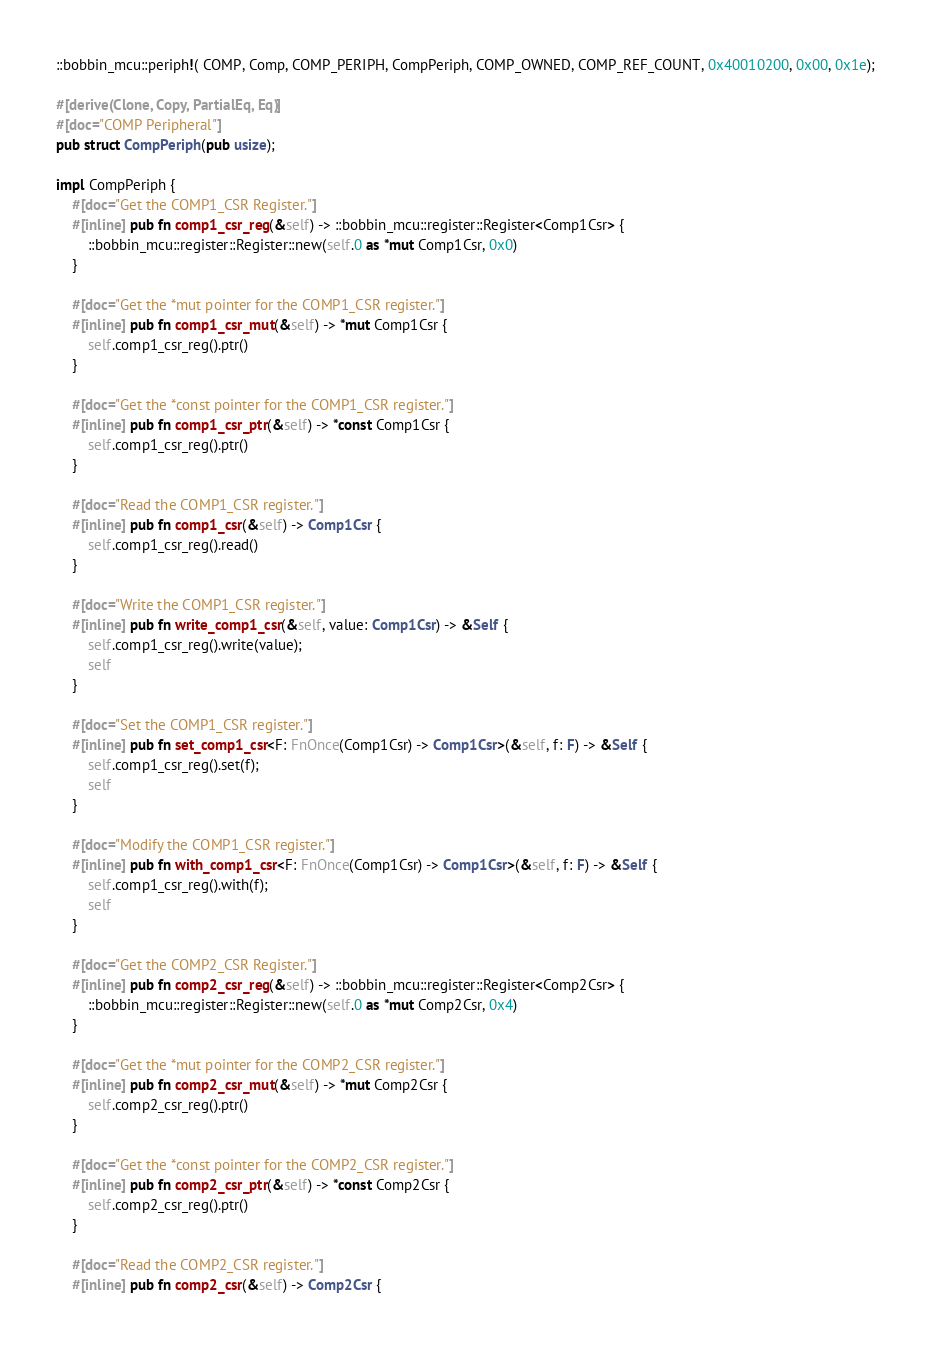<code> <loc_0><loc_0><loc_500><loc_500><_Rust_>::bobbin_mcu::periph!( COMP, Comp, COMP_PERIPH, CompPeriph, COMP_OWNED, COMP_REF_COUNT, 0x40010200, 0x00, 0x1e);

#[derive(Clone, Copy, PartialEq, Eq)]
#[doc="COMP Peripheral"]
pub struct CompPeriph(pub usize); 

impl CompPeriph {
    #[doc="Get the COMP1_CSR Register."]
    #[inline] pub fn comp1_csr_reg(&self) -> ::bobbin_mcu::register::Register<Comp1Csr> { 
        ::bobbin_mcu::register::Register::new(self.0 as *mut Comp1Csr, 0x0)
    }

    #[doc="Get the *mut pointer for the COMP1_CSR register."]
    #[inline] pub fn comp1_csr_mut(&self) -> *mut Comp1Csr { 
        self.comp1_csr_reg().ptr()
    }

    #[doc="Get the *const pointer for the COMP1_CSR register."]
    #[inline] pub fn comp1_csr_ptr(&self) -> *const Comp1Csr { 
        self.comp1_csr_reg().ptr()
    }

    #[doc="Read the COMP1_CSR register."]
    #[inline] pub fn comp1_csr(&self) -> Comp1Csr { 
        self.comp1_csr_reg().read()
    }

    #[doc="Write the COMP1_CSR register."]
    #[inline] pub fn write_comp1_csr(&self, value: Comp1Csr) -> &Self { 
        self.comp1_csr_reg().write(value);
        self
    }

    #[doc="Set the COMP1_CSR register."]
    #[inline] pub fn set_comp1_csr<F: FnOnce(Comp1Csr) -> Comp1Csr>(&self, f: F) -> &Self {
        self.comp1_csr_reg().set(f);
        self
    }

    #[doc="Modify the COMP1_CSR register."]
    #[inline] pub fn with_comp1_csr<F: FnOnce(Comp1Csr) -> Comp1Csr>(&self, f: F) -> &Self {
        self.comp1_csr_reg().with(f);
        self
    }

    #[doc="Get the COMP2_CSR Register."]
    #[inline] pub fn comp2_csr_reg(&self) -> ::bobbin_mcu::register::Register<Comp2Csr> { 
        ::bobbin_mcu::register::Register::new(self.0 as *mut Comp2Csr, 0x4)
    }

    #[doc="Get the *mut pointer for the COMP2_CSR register."]
    #[inline] pub fn comp2_csr_mut(&self) -> *mut Comp2Csr { 
        self.comp2_csr_reg().ptr()
    }

    #[doc="Get the *const pointer for the COMP2_CSR register."]
    #[inline] pub fn comp2_csr_ptr(&self) -> *const Comp2Csr { 
        self.comp2_csr_reg().ptr()
    }

    #[doc="Read the COMP2_CSR register."]
    #[inline] pub fn comp2_csr(&self) -> Comp2Csr { </code> 